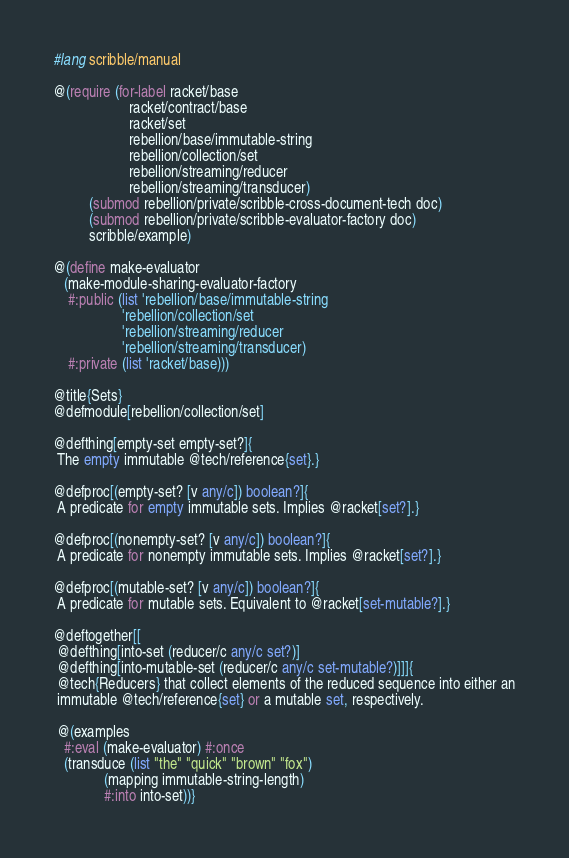Convert code to text. <code><loc_0><loc_0><loc_500><loc_500><_Racket_>#lang scribble/manual

@(require (for-label racket/base
                     racket/contract/base
                     racket/set
                     rebellion/base/immutable-string
                     rebellion/collection/set
                     rebellion/streaming/reducer
                     rebellion/streaming/transducer)
          (submod rebellion/private/scribble-cross-document-tech doc)
          (submod rebellion/private/scribble-evaluator-factory doc)
          scribble/example)

@(define make-evaluator
   (make-module-sharing-evaluator-factory
    #:public (list 'rebellion/base/immutable-string
                   'rebellion/collection/set
                   'rebellion/streaming/reducer
                   'rebellion/streaming/transducer)
    #:private (list 'racket/base)))

@title{Sets}
@defmodule[rebellion/collection/set]

@defthing[empty-set empty-set?]{
 The empty immutable @tech/reference{set}.}

@defproc[(empty-set? [v any/c]) boolean?]{
 A predicate for empty immutable sets. Implies @racket[set?].}

@defproc[(nonempty-set? [v any/c]) boolean?]{
 A predicate for nonempty immutable sets. Implies @racket[set?].}

@defproc[(mutable-set? [v any/c]) boolean?]{
 A predicate for mutable sets. Equivalent to @racket[set-mutable?].}

@deftogether[[
 @defthing[into-set (reducer/c any/c set?)]
 @defthing[into-mutable-set (reducer/c any/c set-mutable?)]]]{
 @tech{Reducers} that collect elements of the reduced sequence into either an
 immutable @tech/reference{set} or a mutable set, respectively.

 @(examples
   #:eval (make-evaluator) #:once
   (transduce (list "the" "quick" "brown" "fox")
              (mapping immutable-string-length)
              #:into into-set))}
</code> 